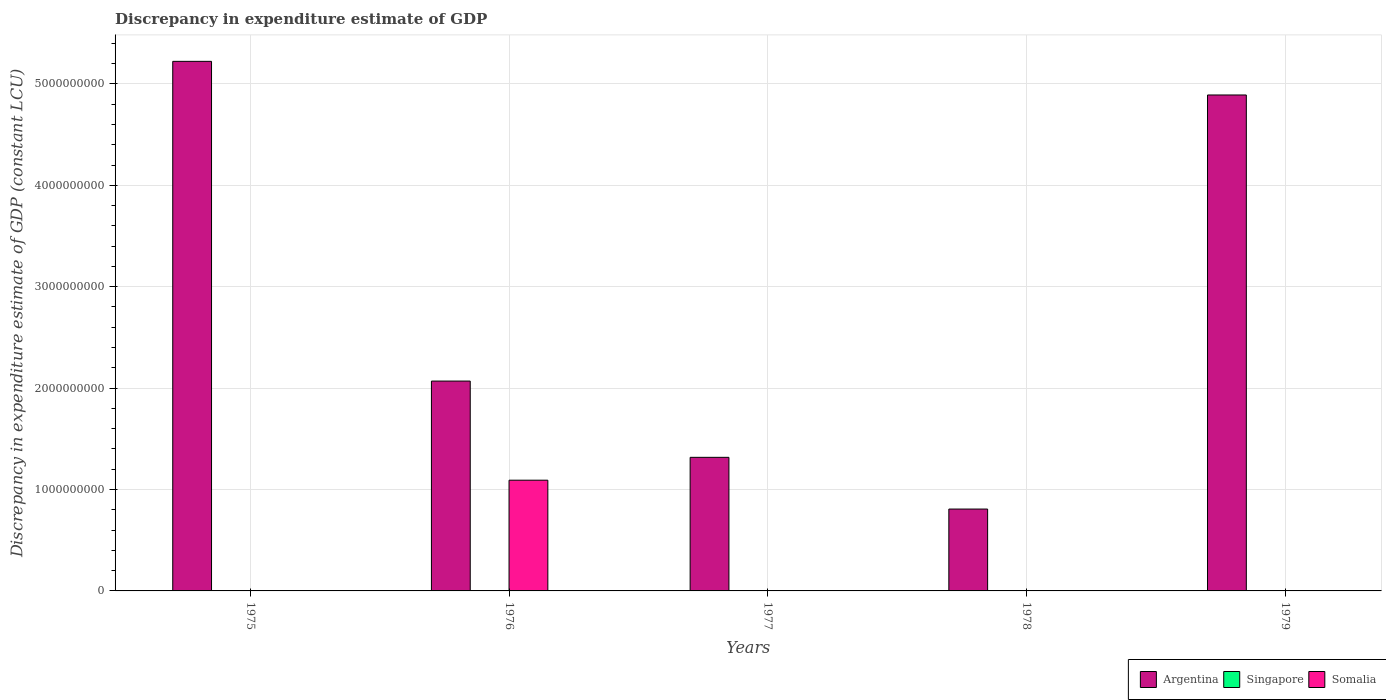Are the number of bars per tick equal to the number of legend labels?
Give a very brief answer. No. How many bars are there on the 4th tick from the left?
Your response must be concise. 2. In how many cases, is the number of bars for a given year not equal to the number of legend labels?
Provide a short and direct response. 5. What is the discrepancy in expenditure estimate of GDP in Somalia in 1975?
Keep it short and to the point. 0. Across all years, what is the maximum discrepancy in expenditure estimate of GDP in Somalia?
Ensure brevity in your answer.  1.09e+09. In which year was the discrepancy in expenditure estimate of GDP in Somalia maximum?
Your answer should be compact. 1976. What is the total discrepancy in expenditure estimate of GDP in Somalia in the graph?
Give a very brief answer. 1.09e+09. What is the difference between the discrepancy in expenditure estimate of GDP in Argentina in 1977 and that in 1978?
Give a very brief answer. 5.10e+08. What is the difference between the discrepancy in expenditure estimate of GDP in Argentina in 1975 and the discrepancy in expenditure estimate of GDP in Singapore in 1979?
Your answer should be very brief. 5.22e+09. What is the average discrepancy in expenditure estimate of GDP in Singapore per year?
Ensure brevity in your answer.  0. In the year 1979, what is the difference between the discrepancy in expenditure estimate of GDP in Somalia and discrepancy in expenditure estimate of GDP in Argentina?
Your response must be concise. -4.89e+09. In how many years, is the discrepancy in expenditure estimate of GDP in Singapore greater than 4200000000 LCU?
Make the answer very short. 0. What is the ratio of the discrepancy in expenditure estimate of GDP in Argentina in 1975 to that in 1976?
Ensure brevity in your answer.  2.52. What is the difference between the highest and the second highest discrepancy in expenditure estimate of GDP in Argentina?
Provide a succinct answer. 3.32e+08. What is the difference between the highest and the lowest discrepancy in expenditure estimate of GDP in Somalia?
Make the answer very short. 1.09e+09. In how many years, is the discrepancy in expenditure estimate of GDP in Somalia greater than the average discrepancy in expenditure estimate of GDP in Somalia taken over all years?
Keep it short and to the point. 1. Are all the bars in the graph horizontal?
Your answer should be compact. No. How many years are there in the graph?
Provide a short and direct response. 5. What is the difference between two consecutive major ticks on the Y-axis?
Give a very brief answer. 1.00e+09. Does the graph contain any zero values?
Ensure brevity in your answer.  Yes. Does the graph contain grids?
Give a very brief answer. Yes. Where does the legend appear in the graph?
Offer a very short reply. Bottom right. How many legend labels are there?
Your response must be concise. 3. How are the legend labels stacked?
Make the answer very short. Horizontal. What is the title of the graph?
Your answer should be very brief. Discrepancy in expenditure estimate of GDP. Does "Tajikistan" appear as one of the legend labels in the graph?
Offer a terse response. No. What is the label or title of the X-axis?
Provide a succinct answer. Years. What is the label or title of the Y-axis?
Provide a succinct answer. Discrepancy in expenditure estimate of GDP (constant LCU). What is the Discrepancy in expenditure estimate of GDP (constant LCU) in Argentina in 1975?
Your answer should be very brief. 5.22e+09. What is the Discrepancy in expenditure estimate of GDP (constant LCU) of Singapore in 1975?
Your response must be concise. 0. What is the Discrepancy in expenditure estimate of GDP (constant LCU) of Somalia in 1975?
Keep it short and to the point. 0. What is the Discrepancy in expenditure estimate of GDP (constant LCU) of Argentina in 1976?
Offer a terse response. 2.07e+09. What is the Discrepancy in expenditure estimate of GDP (constant LCU) of Somalia in 1976?
Provide a succinct answer. 1.09e+09. What is the Discrepancy in expenditure estimate of GDP (constant LCU) in Argentina in 1977?
Give a very brief answer. 1.32e+09. What is the Discrepancy in expenditure estimate of GDP (constant LCU) of Somalia in 1977?
Your answer should be very brief. 0. What is the Discrepancy in expenditure estimate of GDP (constant LCU) of Argentina in 1978?
Offer a terse response. 8.07e+08. What is the Discrepancy in expenditure estimate of GDP (constant LCU) of Somalia in 1978?
Offer a very short reply. 1.05e+06. What is the Discrepancy in expenditure estimate of GDP (constant LCU) of Argentina in 1979?
Ensure brevity in your answer.  4.89e+09. What is the Discrepancy in expenditure estimate of GDP (constant LCU) in Singapore in 1979?
Ensure brevity in your answer.  0. What is the Discrepancy in expenditure estimate of GDP (constant LCU) in Somalia in 1979?
Provide a short and direct response. 1.01e+06. Across all years, what is the maximum Discrepancy in expenditure estimate of GDP (constant LCU) of Argentina?
Provide a short and direct response. 5.22e+09. Across all years, what is the maximum Discrepancy in expenditure estimate of GDP (constant LCU) of Somalia?
Offer a very short reply. 1.09e+09. Across all years, what is the minimum Discrepancy in expenditure estimate of GDP (constant LCU) of Argentina?
Provide a succinct answer. 8.07e+08. What is the total Discrepancy in expenditure estimate of GDP (constant LCU) in Argentina in the graph?
Make the answer very short. 1.43e+1. What is the total Discrepancy in expenditure estimate of GDP (constant LCU) in Singapore in the graph?
Offer a terse response. 0. What is the total Discrepancy in expenditure estimate of GDP (constant LCU) in Somalia in the graph?
Your response must be concise. 1.09e+09. What is the difference between the Discrepancy in expenditure estimate of GDP (constant LCU) of Argentina in 1975 and that in 1976?
Keep it short and to the point. 3.15e+09. What is the difference between the Discrepancy in expenditure estimate of GDP (constant LCU) of Argentina in 1975 and that in 1977?
Ensure brevity in your answer.  3.91e+09. What is the difference between the Discrepancy in expenditure estimate of GDP (constant LCU) in Argentina in 1975 and that in 1978?
Keep it short and to the point. 4.42e+09. What is the difference between the Discrepancy in expenditure estimate of GDP (constant LCU) in Argentina in 1975 and that in 1979?
Your answer should be very brief. 3.32e+08. What is the difference between the Discrepancy in expenditure estimate of GDP (constant LCU) in Argentina in 1976 and that in 1977?
Give a very brief answer. 7.52e+08. What is the difference between the Discrepancy in expenditure estimate of GDP (constant LCU) of Argentina in 1976 and that in 1978?
Your answer should be compact. 1.26e+09. What is the difference between the Discrepancy in expenditure estimate of GDP (constant LCU) in Somalia in 1976 and that in 1978?
Your answer should be compact. 1.09e+09. What is the difference between the Discrepancy in expenditure estimate of GDP (constant LCU) in Argentina in 1976 and that in 1979?
Provide a short and direct response. -2.82e+09. What is the difference between the Discrepancy in expenditure estimate of GDP (constant LCU) in Somalia in 1976 and that in 1979?
Ensure brevity in your answer.  1.09e+09. What is the difference between the Discrepancy in expenditure estimate of GDP (constant LCU) of Argentina in 1977 and that in 1978?
Give a very brief answer. 5.10e+08. What is the difference between the Discrepancy in expenditure estimate of GDP (constant LCU) in Argentina in 1977 and that in 1979?
Your response must be concise. -3.57e+09. What is the difference between the Discrepancy in expenditure estimate of GDP (constant LCU) in Argentina in 1978 and that in 1979?
Ensure brevity in your answer.  -4.08e+09. What is the difference between the Discrepancy in expenditure estimate of GDP (constant LCU) in Somalia in 1978 and that in 1979?
Provide a succinct answer. 4.00e+04. What is the difference between the Discrepancy in expenditure estimate of GDP (constant LCU) in Argentina in 1975 and the Discrepancy in expenditure estimate of GDP (constant LCU) in Somalia in 1976?
Provide a succinct answer. 4.13e+09. What is the difference between the Discrepancy in expenditure estimate of GDP (constant LCU) in Argentina in 1975 and the Discrepancy in expenditure estimate of GDP (constant LCU) in Somalia in 1978?
Give a very brief answer. 5.22e+09. What is the difference between the Discrepancy in expenditure estimate of GDP (constant LCU) in Argentina in 1975 and the Discrepancy in expenditure estimate of GDP (constant LCU) in Somalia in 1979?
Your answer should be very brief. 5.22e+09. What is the difference between the Discrepancy in expenditure estimate of GDP (constant LCU) of Argentina in 1976 and the Discrepancy in expenditure estimate of GDP (constant LCU) of Somalia in 1978?
Your response must be concise. 2.07e+09. What is the difference between the Discrepancy in expenditure estimate of GDP (constant LCU) in Argentina in 1976 and the Discrepancy in expenditure estimate of GDP (constant LCU) in Somalia in 1979?
Offer a terse response. 2.07e+09. What is the difference between the Discrepancy in expenditure estimate of GDP (constant LCU) in Argentina in 1977 and the Discrepancy in expenditure estimate of GDP (constant LCU) in Somalia in 1978?
Your answer should be compact. 1.32e+09. What is the difference between the Discrepancy in expenditure estimate of GDP (constant LCU) in Argentina in 1977 and the Discrepancy in expenditure estimate of GDP (constant LCU) in Somalia in 1979?
Provide a short and direct response. 1.32e+09. What is the difference between the Discrepancy in expenditure estimate of GDP (constant LCU) in Argentina in 1978 and the Discrepancy in expenditure estimate of GDP (constant LCU) in Somalia in 1979?
Your response must be concise. 8.06e+08. What is the average Discrepancy in expenditure estimate of GDP (constant LCU) in Argentina per year?
Offer a very short reply. 2.86e+09. What is the average Discrepancy in expenditure estimate of GDP (constant LCU) of Singapore per year?
Ensure brevity in your answer.  0. What is the average Discrepancy in expenditure estimate of GDP (constant LCU) of Somalia per year?
Provide a short and direct response. 2.19e+08. In the year 1976, what is the difference between the Discrepancy in expenditure estimate of GDP (constant LCU) of Argentina and Discrepancy in expenditure estimate of GDP (constant LCU) of Somalia?
Provide a succinct answer. 9.78e+08. In the year 1978, what is the difference between the Discrepancy in expenditure estimate of GDP (constant LCU) in Argentina and Discrepancy in expenditure estimate of GDP (constant LCU) in Somalia?
Provide a succinct answer. 8.06e+08. In the year 1979, what is the difference between the Discrepancy in expenditure estimate of GDP (constant LCU) of Argentina and Discrepancy in expenditure estimate of GDP (constant LCU) of Somalia?
Ensure brevity in your answer.  4.89e+09. What is the ratio of the Discrepancy in expenditure estimate of GDP (constant LCU) in Argentina in 1975 to that in 1976?
Provide a succinct answer. 2.52. What is the ratio of the Discrepancy in expenditure estimate of GDP (constant LCU) of Argentina in 1975 to that in 1977?
Keep it short and to the point. 3.96. What is the ratio of the Discrepancy in expenditure estimate of GDP (constant LCU) in Argentina in 1975 to that in 1978?
Offer a very short reply. 6.47. What is the ratio of the Discrepancy in expenditure estimate of GDP (constant LCU) in Argentina in 1975 to that in 1979?
Give a very brief answer. 1.07. What is the ratio of the Discrepancy in expenditure estimate of GDP (constant LCU) of Argentina in 1976 to that in 1977?
Make the answer very short. 1.57. What is the ratio of the Discrepancy in expenditure estimate of GDP (constant LCU) in Argentina in 1976 to that in 1978?
Your response must be concise. 2.56. What is the ratio of the Discrepancy in expenditure estimate of GDP (constant LCU) in Somalia in 1976 to that in 1978?
Your response must be concise. 1040. What is the ratio of the Discrepancy in expenditure estimate of GDP (constant LCU) in Argentina in 1976 to that in 1979?
Your response must be concise. 0.42. What is the ratio of the Discrepancy in expenditure estimate of GDP (constant LCU) of Somalia in 1976 to that in 1979?
Offer a terse response. 1081.19. What is the ratio of the Discrepancy in expenditure estimate of GDP (constant LCU) in Argentina in 1977 to that in 1978?
Provide a succinct answer. 1.63. What is the ratio of the Discrepancy in expenditure estimate of GDP (constant LCU) in Argentina in 1977 to that in 1979?
Your response must be concise. 0.27. What is the ratio of the Discrepancy in expenditure estimate of GDP (constant LCU) in Argentina in 1978 to that in 1979?
Ensure brevity in your answer.  0.17. What is the ratio of the Discrepancy in expenditure estimate of GDP (constant LCU) of Somalia in 1978 to that in 1979?
Your answer should be very brief. 1.04. What is the difference between the highest and the second highest Discrepancy in expenditure estimate of GDP (constant LCU) in Argentina?
Offer a terse response. 3.32e+08. What is the difference between the highest and the second highest Discrepancy in expenditure estimate of GDP (constant LCU) in Somalia?
Give a very brief answer. 1.09e+09. What is the difference between the highest and the lowest Discrepancy in expenditure estimate of GDP (constant LCU) of Argentina?
Your answer should be compact. 4.42e+09. What is the difference between the highest and the lowest Discrepancy in expenditure estimate of GDP (constant LCU) of Somalia?
Give a very brief answer. 1.09e+09. 